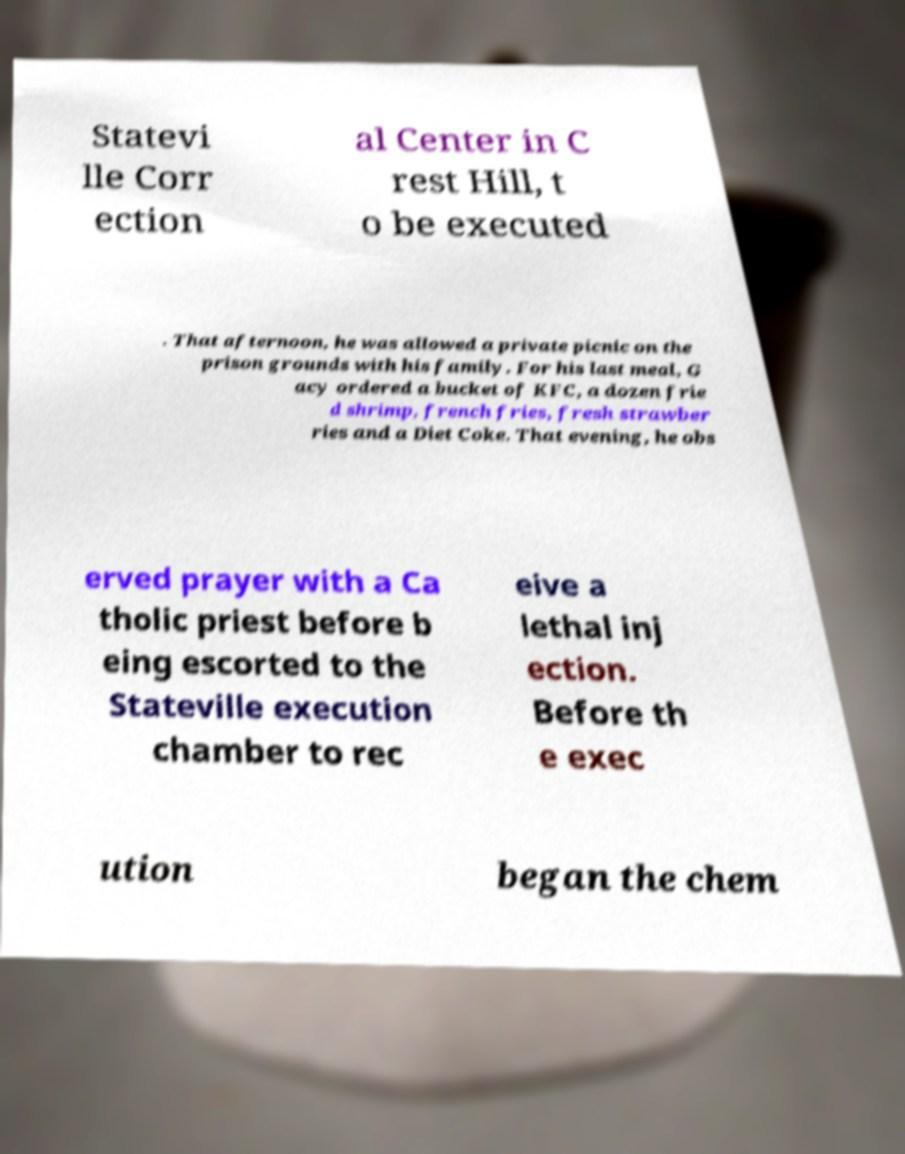Could you assist in decoding the text presented in this image and type it out clearly? Statevi lle Corr ection al Center in C rest Hill, t o be executed . That afternoon, he was allowed a private picnic on the prison grounds with his family. For his last meal, G acy ordered a bucket of KFC, a dozen frie d shrimp, french fries, fresh strawber ries and a Diet Coke. That evening, he obs erved prayer with a Ca tholic priest before b eing escorted to the Stateville execution chamber to rec eive a lethal inj ection. Before th e exec ution began the chem 